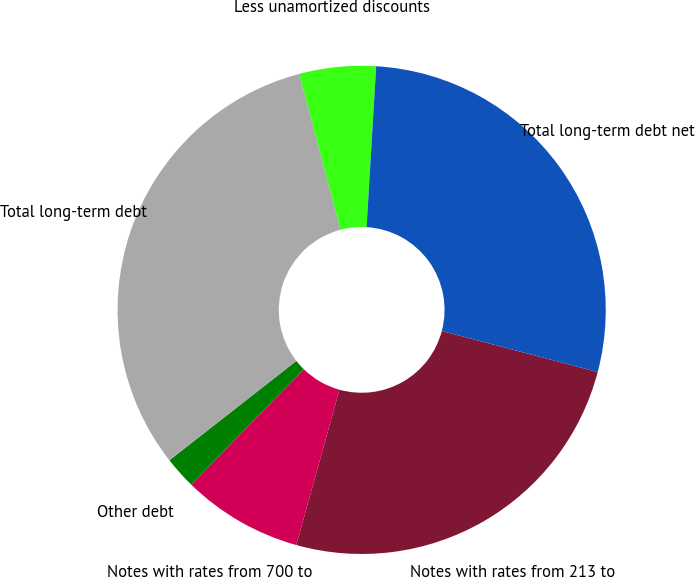Convert chart. <chart><loc_0><loc_0><loc_500><loc_500><pie_chart><fcel>Notes with rates from 213 to<fcel>Notes with rates from 700 to<fcel>Other debt<fcel>Total long-term debt<fcel>Less unamortized discounts<fcel>Total long-term debt net<nl><fcel>25.22%<fcel>7.99%<fcel>2.13%<fcel>31.45%<fcel>5.06%<fcel>28.15%<nl></chart> 